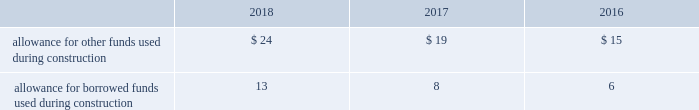Investment tax credits have been deferred by the regulated utility subsidiaries and are being amortized to income over the average estimated service lives of the related assets .
The company recognizes accrued interest and penalties related to tax positions as a component of income tax expense and accounts for sales tax collected from customers and remitted to taxing authorities on a net basis .
See note 14 2014income taxes for additional information .
Allowance for funds used during construction afudc is a non-cash credit to income with a corresponding charge to utility plant that represents the cost of borrowed funds or a return on equity funds devoted to plant under construction .
The regulated utility subsidiaries record afudc to the extent permitted by the pucs .
The portion of afudc attributable to borrowed funds is shown as a reduction of interest , net on the consolidated statements of operations .
Any portion of afudc attributable to equity funds would be included in other , net on the consolidated statements of operations .
Afudc is provided in the table for the years ended december 31: .
Environmental costs the company 2019s water and wastewater operations and the operations of its market-based businesses are subject to u.s .
Federal , state , local and foreign requirements relating to environmental protection , and as such , the company periodically becomes subject to environmental claims in the normal course of business .
Environmental expenditures that relate to current operations or provide a future benefit are expensed or capitalized as appropriate .
Remediation costs that relate to an existing condition caused by past operations are accrued , on an undiscounted basis , when it is probable that these costs will be incurred and can be reasonably estimated .
A conservation agreement entered into by a subsidiary of the company with the national oceanic and atmospheric administration in 2010 and amended in 2017 required the subsidiary to , among other provisions , implement certain measures to protect the steelhead trout and its habitat in the carmel river watershed in the state of california .
The subsidiary agreed to pay $ 1 million annually commencing in 2010 with the final payment being made in 2021 .
Remediation costs accrued amounted to $ 4 million and $ 6 million as of december 31 , 2018 and 2017 , respectively .
Derivative financial instruments the company uses derivative financial instruments for purposes of hedging exposures to fluctuations in interest rates .
These derivative contracts are entered into for periods consistent with the related underlying exposures and do not constitute positions independent of those exposures .
The company does not enter into derivative contracts for speculative purposes and does not use leveraged instruments .
All derivatives are recognized on the balance sheet at fair value .
On the date the derivative contract is entered into , the company may designate the derivative as a hedge of the fair value of a recognized asset or liability ( fair-value hedge ) or a hedge of a forecasted transaction or of the variability of cash flows to be received or paid related to a recognized asset or liability ( cash-flow hedge ) .
Changes in the fair value of a fair-value hedge , along with the gain or loss on the underlying hedged item , are recorded in current-period earnings .
The gains and losses on the effective portion of cash-flow hedges are recorded in other comprehensive income , until earnings are affected by the variability of cash flows .
Any ineffective portion of designated cash-flow hedges is recognized in current-period earnings. .
What was total allowance for borrowed funds used during construction in the table? 
Computations: table_sum(allowance for borrowed funds used during construction, none)
Answer: 27.0. 